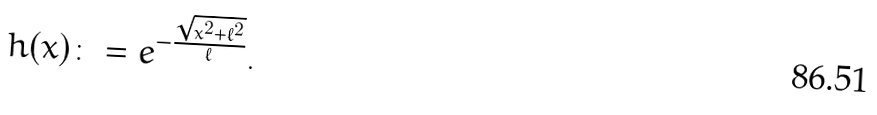Convert formula to latex. <formula><loc_0><loc_0><loc_500><loc_500>h ( x ) \colon = e ^ { - \frac { \sqrt { x ^ { 2 } + \ell ^ { 2 } } } { \ell } } .</formula> 